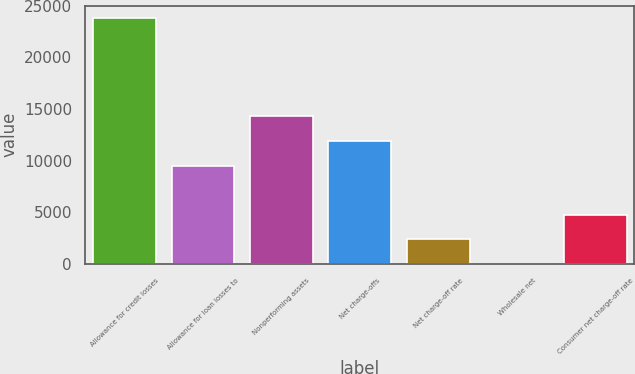Convert chart. <chart><loc_0><loc_0><loc_500><loc_500><bar_chart><fcel>Allowance for credit losses<fcel>Allowance for loan losses to<fcel>Nonperforming assets<fcel>Net charge-offs<fcel>Net charge-off rate<fcel>Wholesale net<fcel>Consumer net charge-off rate<nl><fcel>23823<fcel>9529.3<fcel>14293.9<fcel>11911.6<fcel>2382.46<fcel>0.18<fcel>4764.74<nl></chart> 